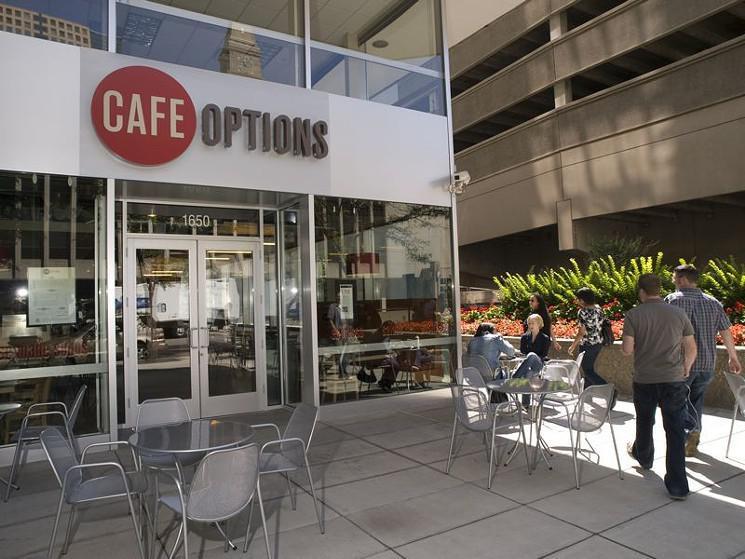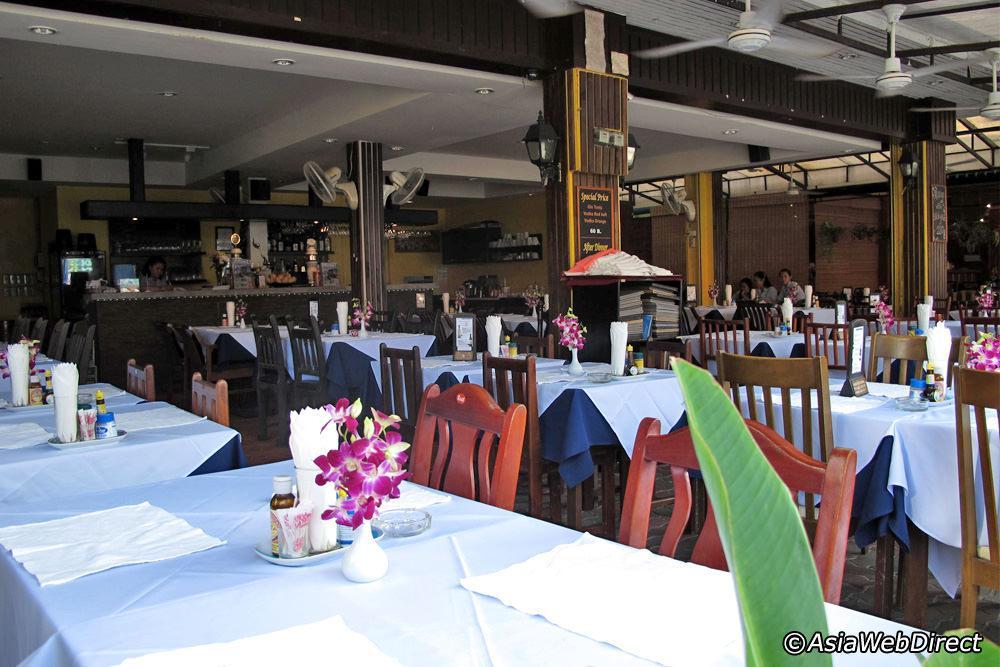The first image is the image on the left, the second image is the image on the right. For the images shown, is this caption "One image shows a restaurant with a black band running around the top, with white lettering on it, and at least one rectangular upright stand under it." true? Answer yes or no. No. The first image is the image on the left, the second image is the image on the right. Evaluate the accuracy of this statement regarding the images: "There are people sitting in chairs in the left image.". Is it true? Answer yes or no. Yes. 